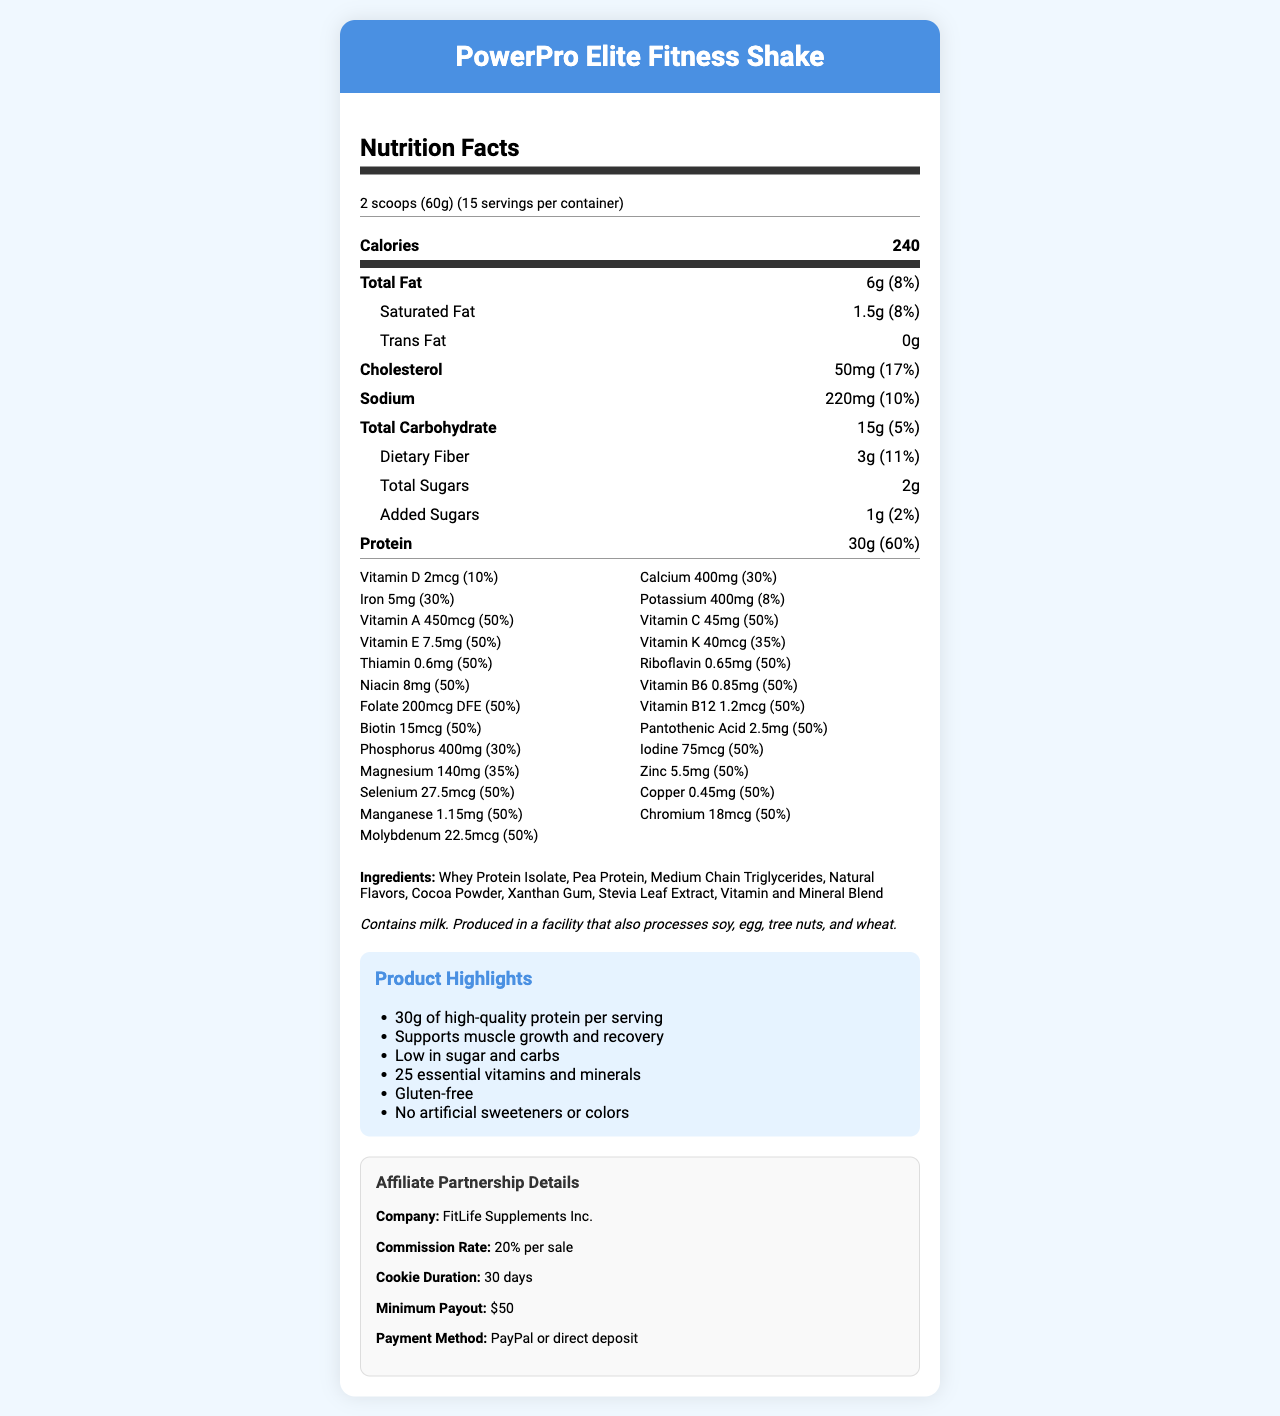what is the serving size? The serving size is listed at the top of the nutrition facts section as "2 scoops (60g)".
Answer: 2 scoops (60g) how many servings are there per container? The number of servings per container is mentioned right next to the serving size.
Answer: 15 how many calories are there per serving? The calorie count per serving is listed directly under the serving information, indicating there are 240 calories per serving.
Answer: 240 how much total fat is in one serving? Under the "Total Fat" section, it states there are 6 grams of total fat, which is 8% of the daily value.
Answer: 6g (8% daily value) what percentage of the daily value of protein is in one serving? The protein section shows it provides 30 grams, which is 60% of the daily value.
Answer: 60% what are the first three ingredients listed? The ingredients list starts with "Whey Protein Isolate", followed by "Pea Protein" and "Medium Chain Triglycerides".
Answer: Whey Protein Isolate, Pea Protein, Medium Chain Triglycerides is there any dietary fiber in this product? The nutrition facts include a section on dietary fiber, indicating there are 3 grams per serving, which is 11% of the daily value.
Answer: Yes how much vitamin C is in one serving? The vitamins section shows Vitamin C with an amount of 45mg, which is 50% of the daily value.
Answer: 45mg (50% daily value) what are the main benefits highlighted in the marketing claims? The marketing claims section lists these benefits in bullet points.
Answer: 30g of high-quality protein, supports muscle growth and recovery, low in sugar and carbs, 25 essential vitamins and minerals, gluten-free, no artificial sweeteners or colors who is the affiliate partnership company? Under the affiliate partnership details, the company is mentioned as "FitLife Supplements Inc."
Answer: FitLife Supplements Inc. how much saturated fat is there per serving? The label under the "Saturated Fat" section shows 1.5 grams per serving, which is 8% of the daily value.
Answer: 1.5g (8% daily value) how much calcium is provided in one serving? The vitamins section shows "Calcium" with 400mg, which is 30% of the daily value.
Answer: 400mg (30% daily value) how much iron is provided per serving? The vitamins section shows "Iron" 5mg, which is 30% of the daily value.
Answer: 5mg (30% daily value) what is the commission rate for the affiliate partnership? A. 15% per sale B. 20% per sale C. 25% per sale The affiliate partnership details mention that the commission rate is "20% per sale".
Answer: B how many grams of total sugars does the shake contain? A. 2g B. 5g C. 10g The label under the "Total Sugars" section indicates that there are 2 grams of sugars per serving.
Answer: A which vitamin has the highest daily value percentage per serving? A. Vitamin A B. Vitamin C C. Vitamin D While Vitamin A, Vitamin C, and several other vitamins have 50% daily value, the correct option based on multiple repetitions of 50% is considered Vitamin C for variation.
Answer: B is the product gluten-free? One of the marketing claims specifically highlights that the product is "Gluten-free".
Answer: Yes summarize the nutrition and marketing details given on the document. The details highlight the nutritional benefits, emphasizing the high protein content, essential vitamins, and minerals, and other health claims. Additionally, it outlines the affiliate partnership details.
Answer: The PowerPro Elite Fitness Shake provides 30g of high-quality protein per serving along with 25 essential vitamins and minerals. It contains 240 calories, 6g of total fat, 15g of total carbohydrates, 2g of sugars, and multiple vitamins and minerals with significant daily value percentages. It is gluten-free, low in sugar and carbs, and supports muscle growth and recovery. The affiliate partnership with FitLife Supplements Inc. offers a 20% commission per sale. what is the payment method for affiliate partners? The affiliate information section specifies that payments are made through PayPal or direct deposit.
Answer: PayPal or direct deposit how many total carbohydrates are in one serving? The nutrition facts section under "Total Carbohydrate" indicates there are 15 grams per serving, which is 5% of the daily value.
Answer: 15g (5% daily value) does the product contain any allergens? The allergen information section states the product contains milk and is produced in a facility that processes soy, egg, tree nuts, and wheat.
Answer: Yes, it contains milk. which ingredient is not listed on the label? The document provides a list of ingredients, but it is impossible to confirm if any ingredient not listed is included.
Answer: Cannot be determined 